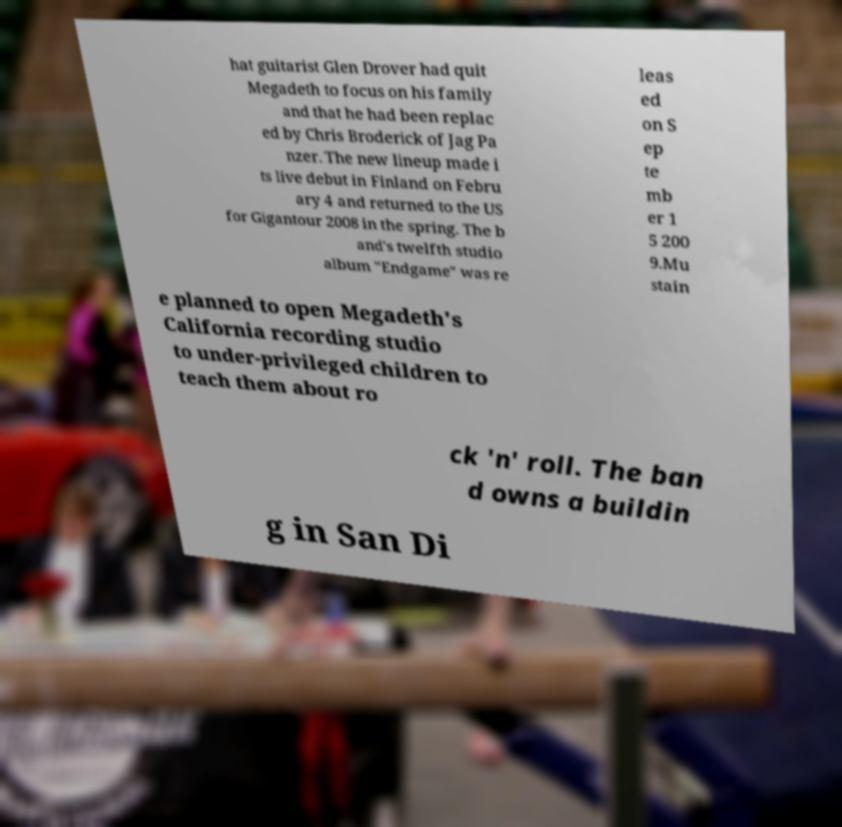What messages or text are displayed in this image? I need them in a readable, typed format. hat guitarist Glen Drover had quit Megadeth to focus on his family and that he had been replac ed by Chris Broderick of Jag Pa nzer. The new lineup made i ts live debut in Finland on Febru ary 4 and returned to the US for Gigantour 2008 in the spring. The b and's twelfth studio album "Endgame" was re leas ed on S ep te mb er 1 5 200 9.Mu stain e planned to open Megadeth's California recording studio to under-privileged children to teach them about ro ck 'n' roll. The ban d owns a buildin g in San Di 